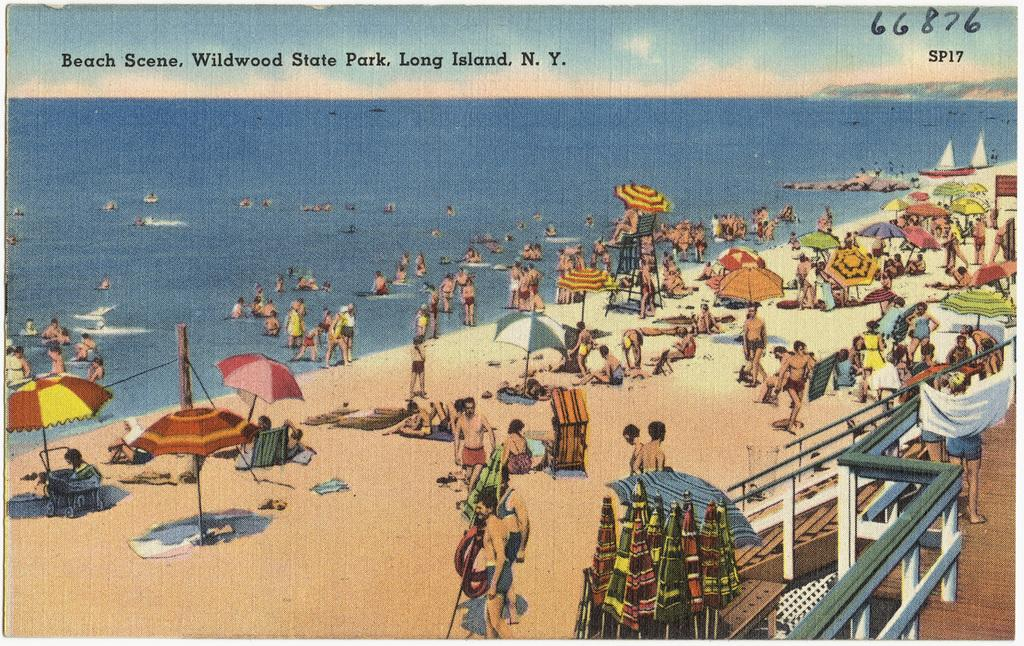Provide a one-sentence caption for the provided image. A painting of an ocean beach packed with people in Long Island, N. Y. 